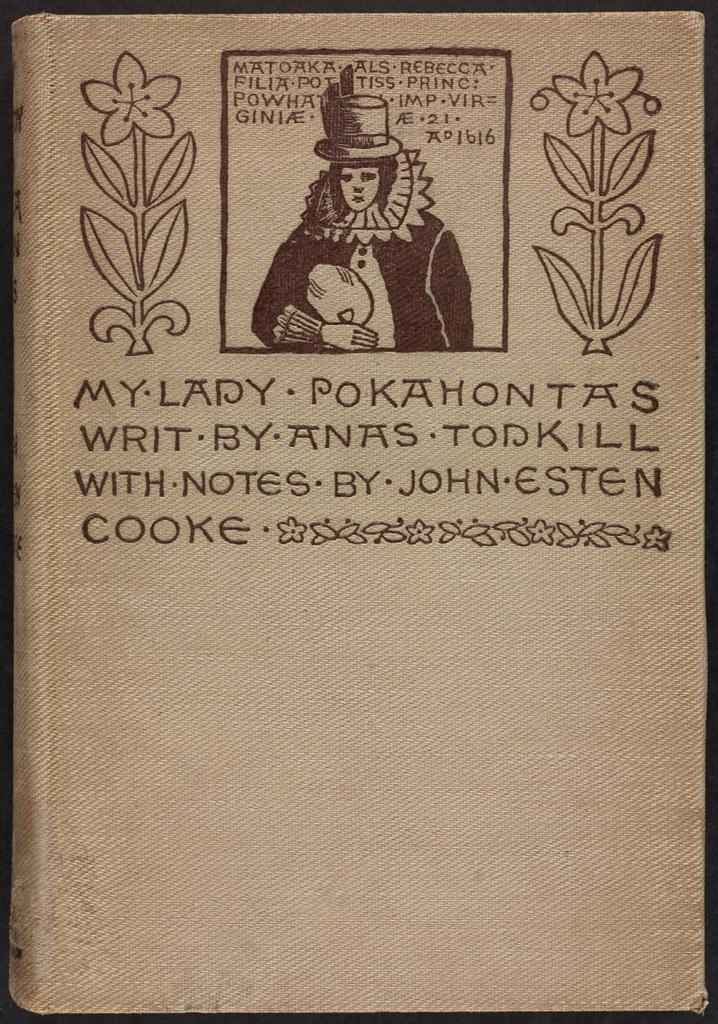What is the main element of the image? The image contains a cover page. What can be found on the cover page? The cover page has text on it and a depiction of a person. Are there any additional elements on the cover page? Yes, the cover page includes flowers. How is the cover page framed within the image? The image has borders. Can you see a man holding a gun in the image? No, there is no man holding a gun in the image. The image only contains a cover page with text, a person, flowers, and borders. 